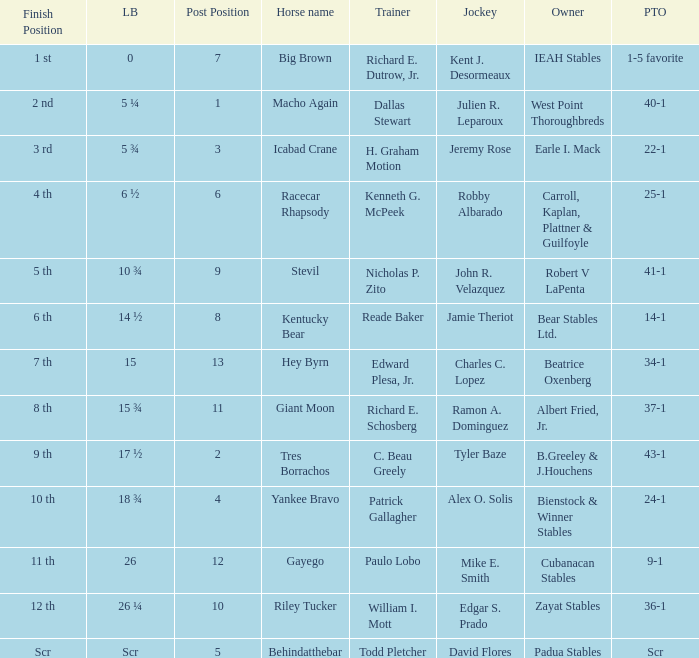Who is the owner of Icabad Crane? Earle I. Mack. 